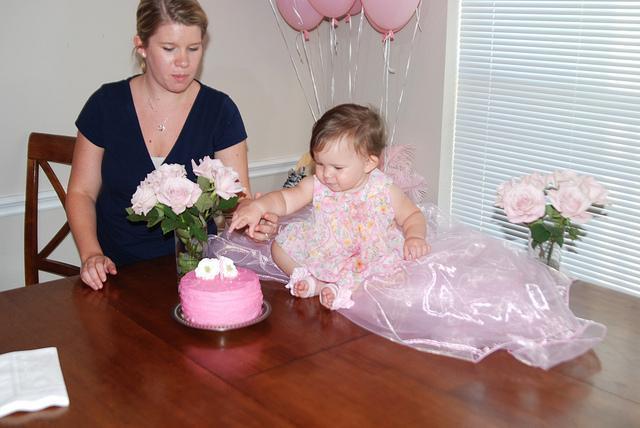How many people are there?
Give a very brief answer. 2. 